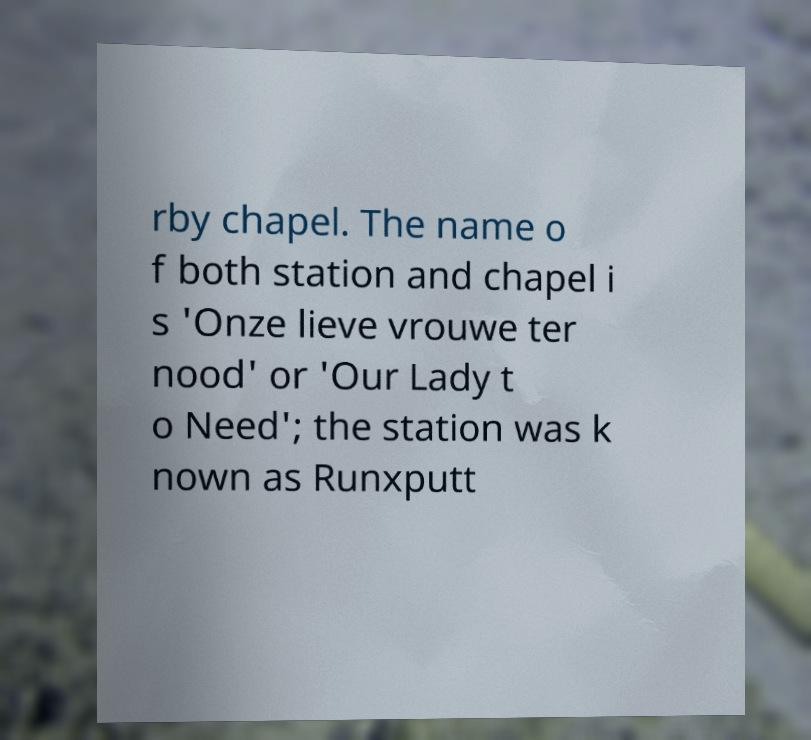Could you assist in decoding the text presented in this image and type it out clearly? rby chapel. The name o f both station and chapel i s 'Onze lieve vrouwe ter nood' or 'Our Lady t o Need'; the station was k nown as Runxputt 